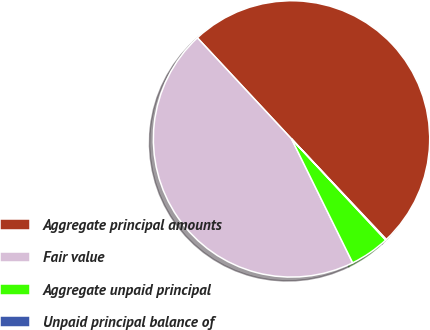<chart> <loc_0><loc_0><loc_500><loc_500><pie_chart><fcel>Aggregate principal amounts<fcel>Fair value<fcel>Aggregate unpaid principal<fcel>Unpaid principal balance of<nl><fcel>49.91%<fcel>45.36%<fcel>4.64%<fcel>0.09%<nl></chart> 